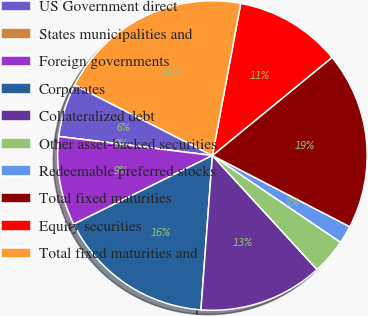Convert chart to OTSL. <chart><loc_0><loc_0><loc_500><loc_500><pie_chart><fcel>US Government direct<fcel>States municipalities and<fcel>Foreign governments<fcel>Corporates<fcel>Collateralized debt<fcel>Other asset-backed securities<fcel>Redeemable preferred stocks<fcel>Total fixed maturities<fcel>Equity securities<fcel>Total fixed maturities and<nl><fcel>5.57%<fcel>0.0%<fcel>9.28%<fcel>16.5%<fcel>13.0%<fcel>3.71%<fcel>1.86%<fcel>18.54%<fcel>11.14%<fcel>20.4%<nl></chart> 